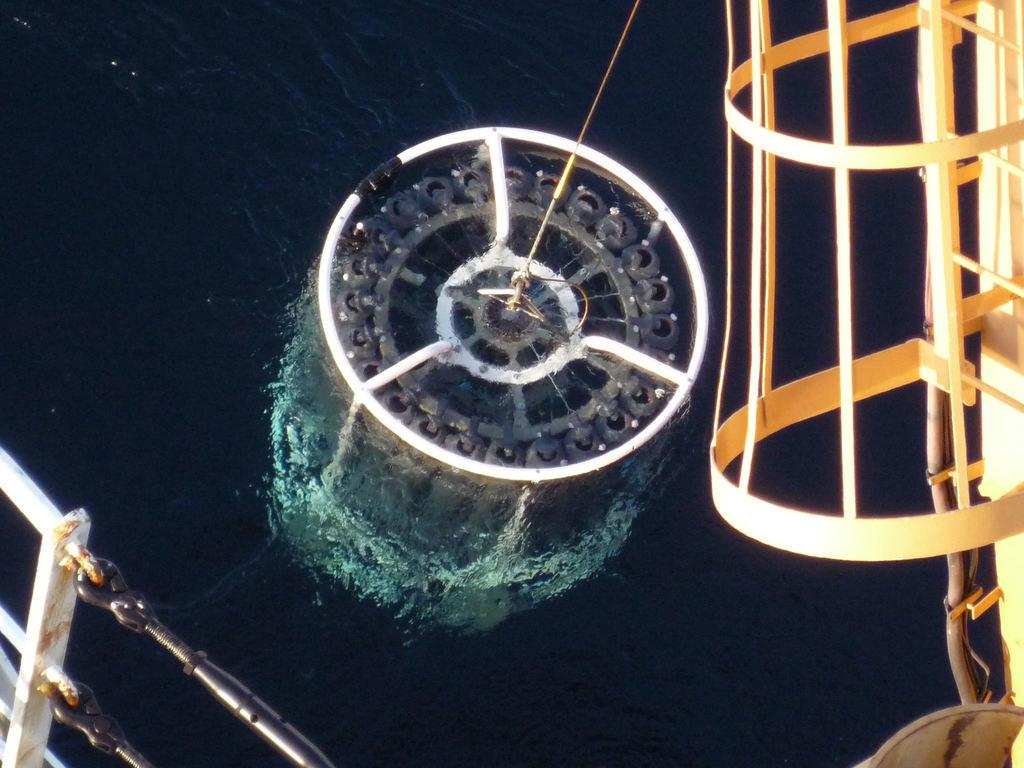What type of object can be seen with a string in the image? There is a metal object with a string in the image. What can be seen in the background of the image? Water is visible in the image. What type of treatment is being administered to the jelly in the image? There is no jelly present in the image, so no treatment can be administered to it. 